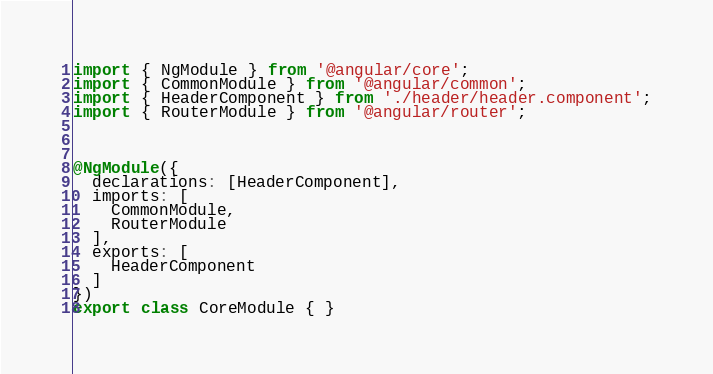Convert code to text. <code><loc_0><loc_0><loc_500><loc_500><_TypeScript_>import { NgModule } from '@angular/core';
import { CommonModule } from '@angular/common';
import { HeaderComponent } from './header/header.component';
import { RouterModule } from '@angular/router';



@NgModule({
  declarations: [HeaderComponent],
  imports: [
    CommonModule,
    RouterModule
  ],
  exports: [
    HeaderComponent
  ]
})
export class CoreModule { }
</code> 